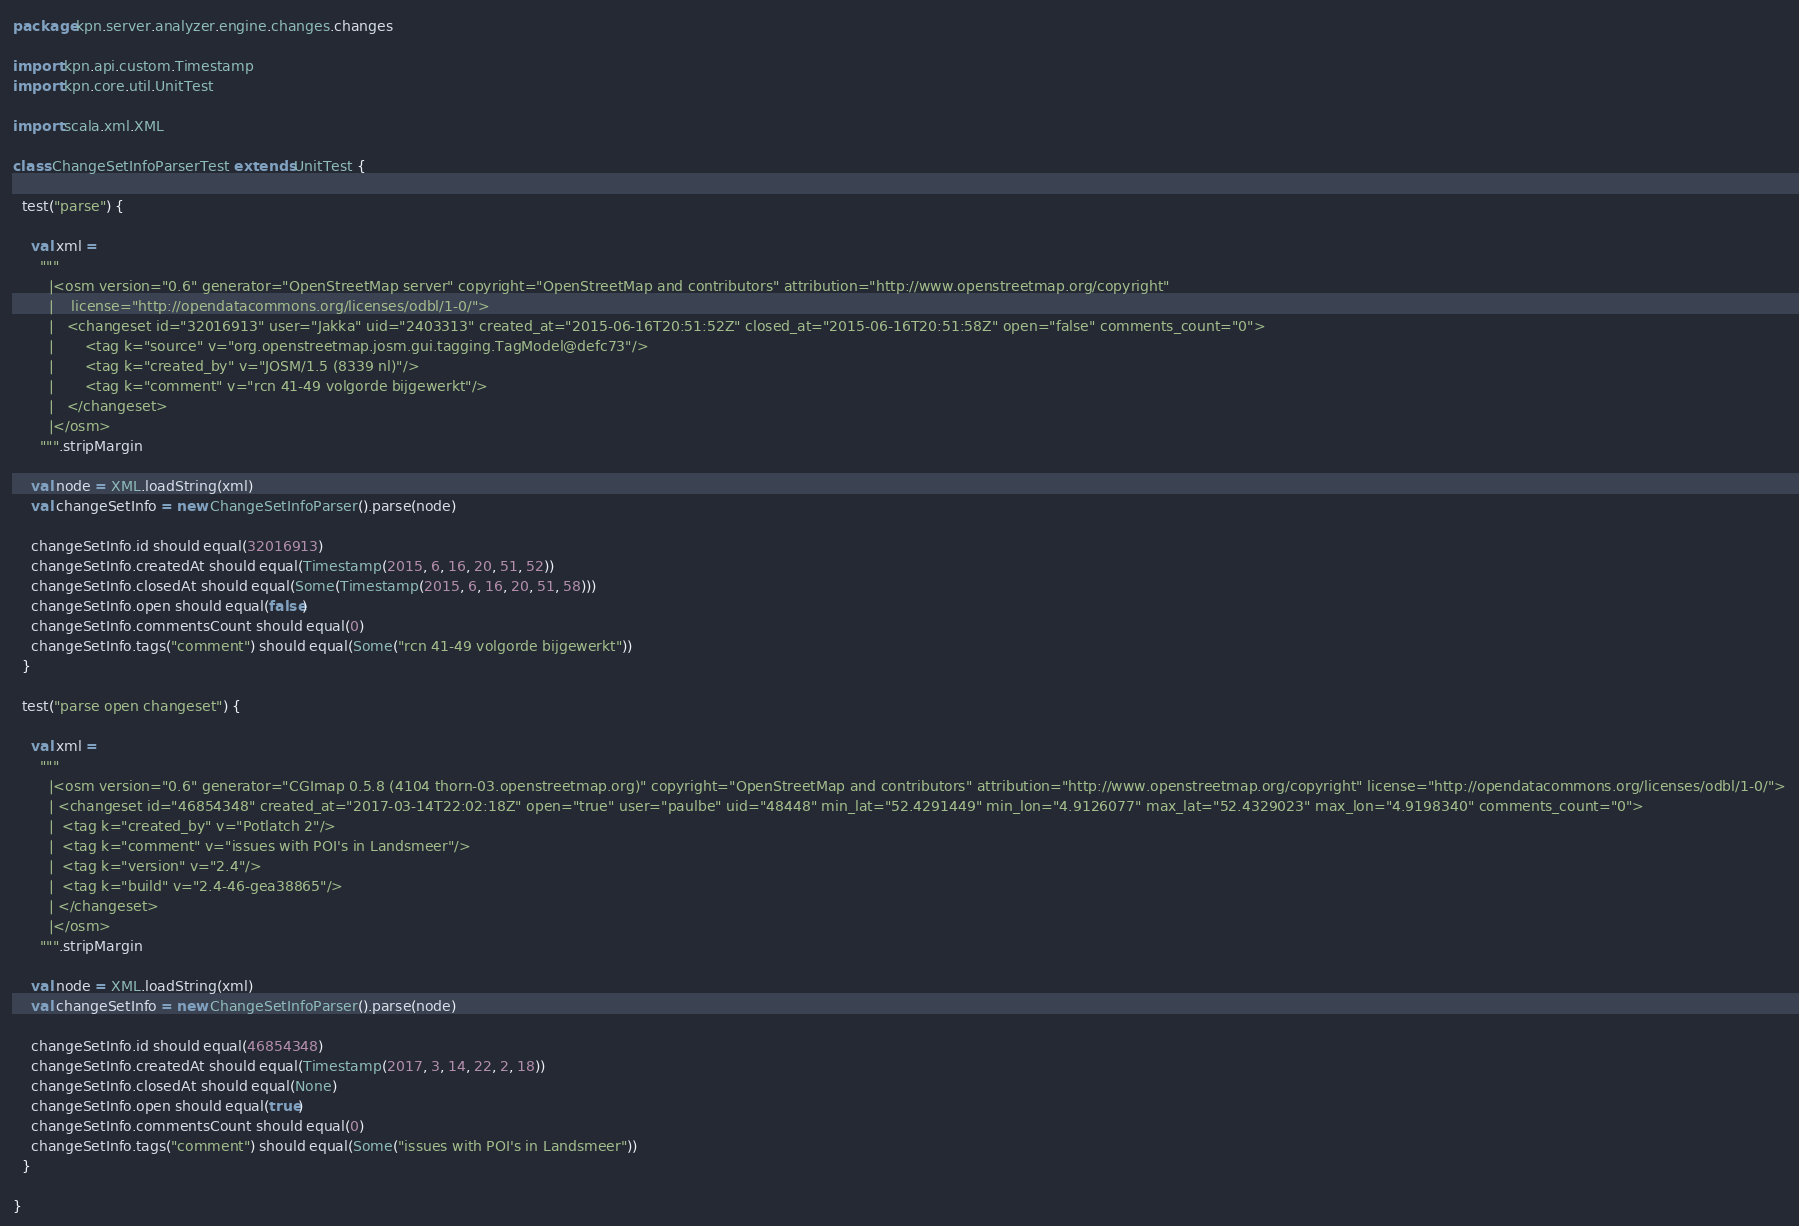Convert code to text. <code><loc_0><loc_0><loc_500><loc_500><_Scala_>package kpn.server.analyzer.engine.changes.changes

import kpn.api.custom.Timestamp
import kpn.core.util.UnitTest

import scala.xml.XML

class ChangeSetInfoParserTest extends UnitTest {

  test("parse") {

    val xml =
      """
        |<osm version="0.6" generator="OpenStreetMap server" copyright="OpenStreetMap and contributors" attribution="http://www.openstreetmap.org/copyright"
        |	 license="http://opendatacommons.org/licenses/odbl/1-0/">
        |	<changeset id="32016913" user="Jakka" uid="2403313" created_at="2015-06-16T20:51:52Z" closed_at="2015-06-16T20:51:58Z" open="false" comments_count="0">
        |		<tag k="source" v="org.openstreetmap.josm.gui.tagging.TagModel@defc73"/>
        |		<tag k="created_by" v="JOSM/1.5 (8339 nl)"/>
        |		<tag k="comment" v="rcn 41-49 volgorde bijgewerkt"/>
        |	</changeset>
        |</osm>
      """.stripMargin

    val node = XML.loadString(xml)
    val changeSetInfo = new ChangeSetInfoParser().parse(node)

    changeSetInfo.id should equal(32016913)
    changeSetInfo.createdAt should equal(Timestamp(2015, 6, 16, 20, 51, 52))
    changeSetInfo.closedAt should equal(Some(Timestamp(2015, 6, 16, 20, 51, 58)))
    changeSetInfo.open should equal(false)
    changeSetInfo.commentsCount should equal(0)
    changeSetInfo.tags("comment") should equal(Some("rcn 41-49 volgorde bijgewerkt"))
  }

  test("parse open changeset") {

    val xml =
      """
        |<osm version="0.6" generator="CGImap 0.5.8 (4104 thorn-03.openstreetmap.org)" copyright="OpenStreetMap and contributors" attribution="http://www.openstreetmap.org/copyright" license="http://opendatacommons.org/licenses/odbl/1-0/">
        | <changeset id="46854348" created_at="2017-03-14T22:02:18Z" open="true" user="paulbe" uid="48448" min_lat="52.4291449" min_lon="4.9126077" max_lat="52.4329023" max_lon="4.9198340" comments_count="0">
        |  <tag k="created_by" v="Potlatch 2"/>
        |  <tag k="comment" v="issues with POI's in Landsmeer"/>
        |  <tag k="version" v="2.4"/>
        |  <tag k="build" v="2.4-46-gea38865"/>
        | </changeset>
        |</osm>
      """.stripMargin

    val node = XML.loadString(xml)
    val changeSetInfo = new ChangeSetInfoParser().parse(node)

    changeSetInfo.id should equal(46854348)
    changeSetInfo.createdAt should equal(Timestamp(2017, 3, 14, 22, 2, 18))
    changeSetInfo.closedAt should equal(None)
    changeSetInfo.open should equal(true)
    changeSetInfo.commentsCount should equal(0)
    changeSetInfo.tags("comment") should equal(Some("issues with POI's in Landsmeer"))
  }

}
</code> 